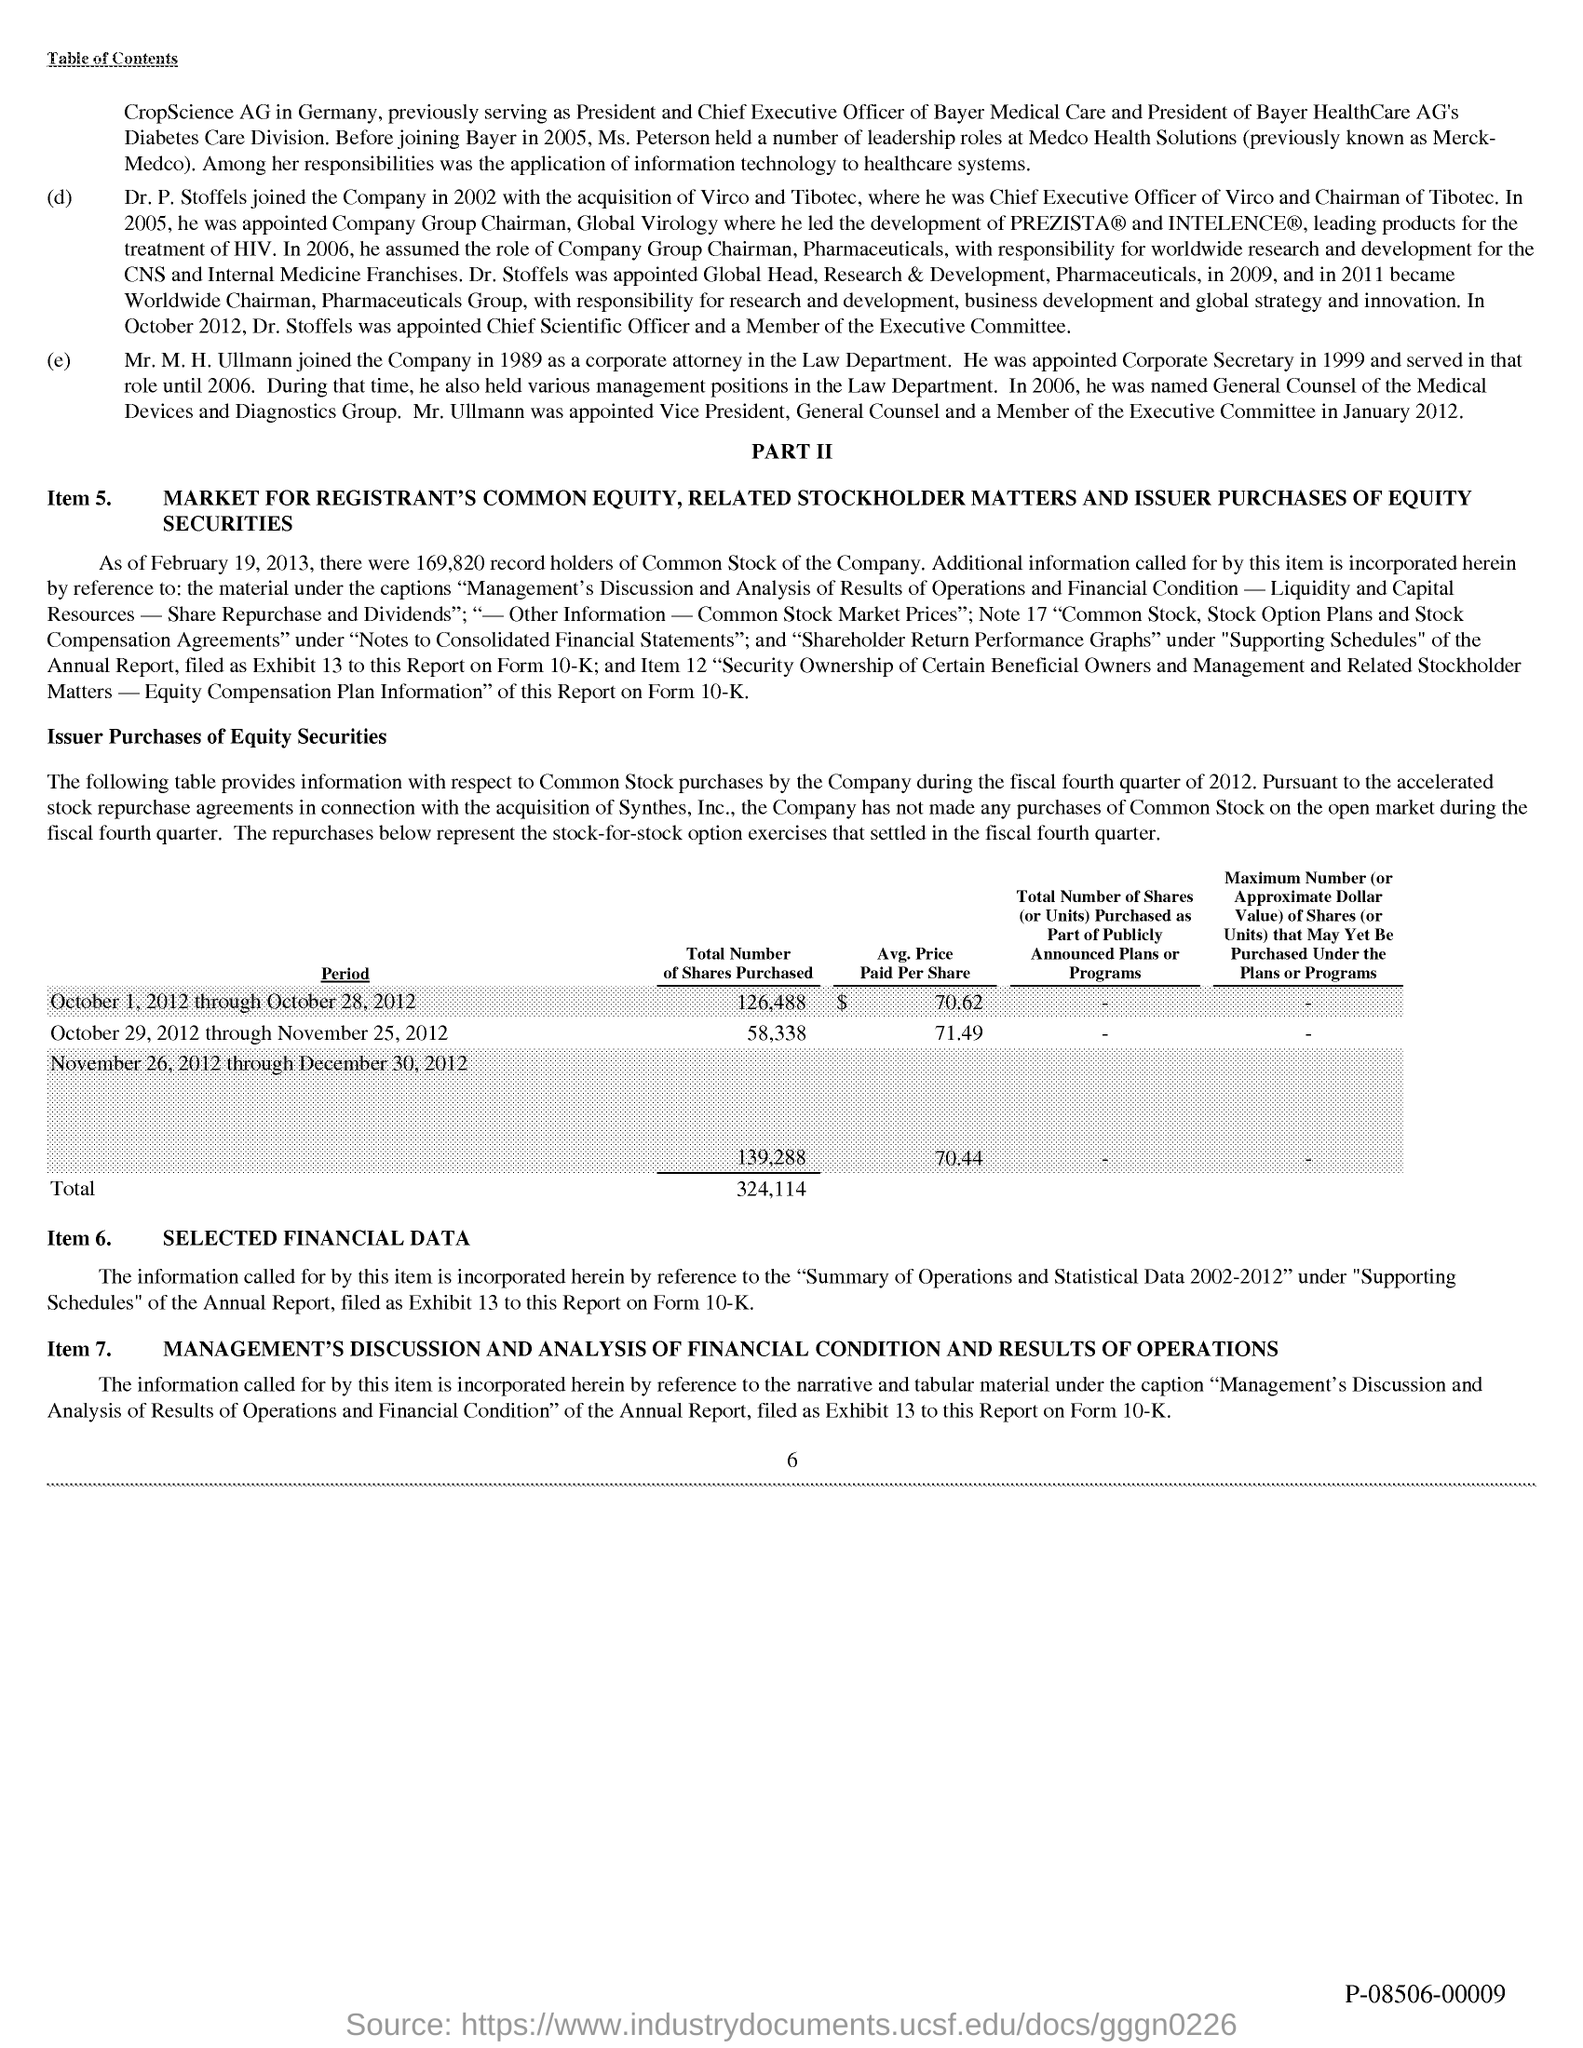Highlight a few significant elements in this photo. What is the page number?" the teacher asked, pointing to the sixth page of the lesson plan. 